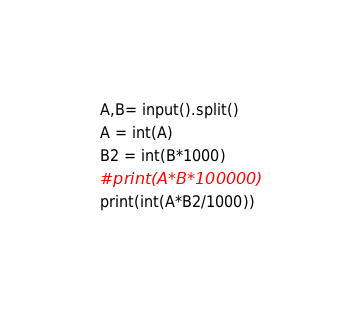<code> <loc_0><loc_0><loc_500><loc_500><_Python_>A,B= input().split()
A = int(A)
B2 = int(B*1000)
#print(A*B*100000)
print(int(A*B2/1000))</code> 